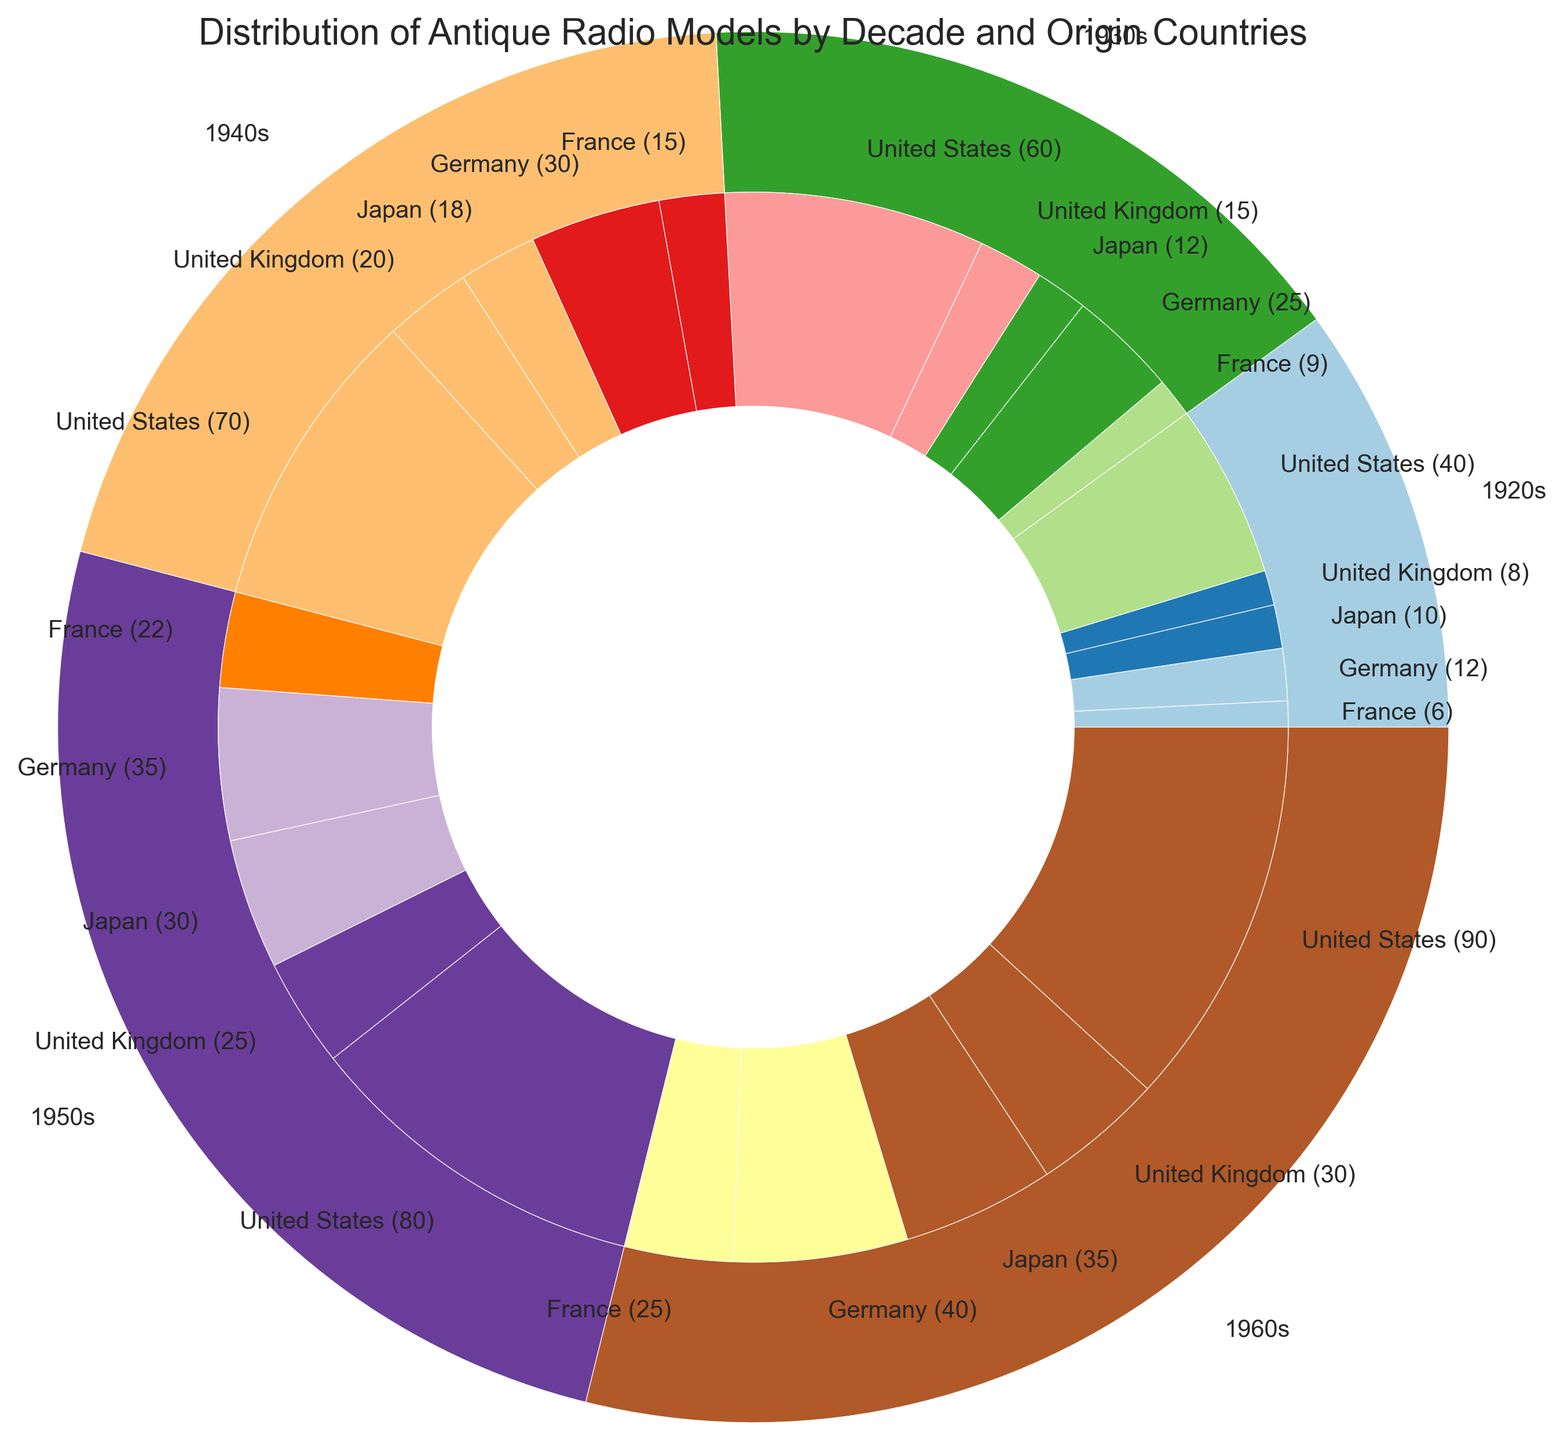What decade had the highest number of antique radio models from Japan? To determine the decade with the highest number of antique radio models from Japan, look at the inner labels for Japan across all decades and compare their counts. The 1960s show the highest count of 35.
Answer: 1960s Which country contributed the most models in the 1920s? For the 1920s segment, look at the inner labels and identify the country with the highest count. The United States has the highest count with 40 models.
Answer: United States How many antique radio models were produced in the 1930s by Germany and France combined? Find the inner labels corresponding to Germany and France for the 1930s and sum their counts: Germany (25) + France (9) = 34.
Answer: 34 Is the total number of models in the 1950s greater than the 1940s? Compare the outer segment labels for the 1950s and 1940s. The 1950s have 80 (US) + 35 (Germany) + 25 (UK) + 22 (France) + 30 (Japan) = 192, whereas the 1940s have 70 (US) + 30 (Germany) + 20 (UK) + 15 (France) + 18 (Japan) = 153. Thus, 1950s > 1940s.
Answer: Yes What is the total count of antique radio models from the United States across all decades? Sum the counts from the inner labels for the United States across all decades: 40 (1920s) + 60 (1930s) + 70 (1940s) + 80 (1950s) + 90 (1960s) = 340.
Answer: 340 Which decade had the least number of models from France? Compare the inner labels for France across all decades. The decade with the least number is the 1920s with 6 models.
Answer: 1920s Is the number of models from the United Kingdom in the 1960s higher than in the 1950s? Compare the inner labels for the United Kingdom in the 1960s and 1950s. The counts are 30 (1960s) and 25 (1950s), with the 1960s count being higher.
Answer: Yes Which country has increased its production every decade from 1920s to 1960s? Look at the inner labels for each country through the decades and check for consistent increase. The United States has increased counts: 40 (1920s), 60 (1930s), 70 (1940s), 80 (1950s), 90 (1960s).
Answer: United States 